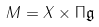Convert formula to latex. <formula><loc_0><loc_0><loc_500><loc_500>M = X \times \Pi \mathfrak { g }</formula> 